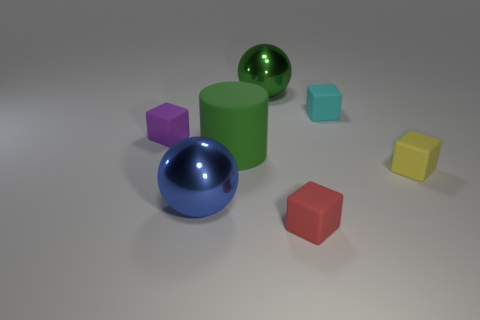Subtract all small purple matte blocks. How many blocks are left? 3 Subtract 2 blocks. How many blocks are left? 2 Add 1 large green rubber cylinders. How many objects exist? 8 Subtract all cyan cubes. How many cubes are left? 3 Subtract all cubes. How many objects are left? 3 Add 6 tiny purple matte objects. How many tiny purple matte objects are left? 7 Add 1 cyan rubber blocks. How many cyan rubber blocks exist? 2 Subtract 0 brown cylinders. How many objects are left? 7 Subtract all purple cubes. Subtract all brown cylinders. How many cubes are left? 3 Subtract all tiny blue cylinders. Subtract all blue metallic balls. How many objects are left? 6 